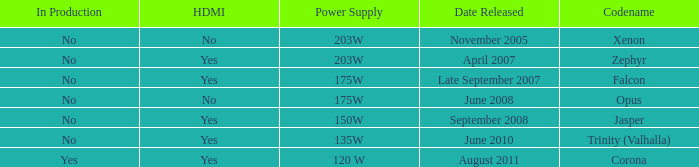Is Jasper being producted? No. Would you be able to parse every entry in this table? {'header': ['In Production', 'HDMI', 'Power Supply', 'Date Released', 'Codename'], 'rows': [['No', 'No', '203W', 'November 2005', 'Xenon'], ['No', 'Yes', '203W', 'April 2007', 'Zephyr'], ['No', 'Yes', '175W', 'Late September 2007', 'Falcon'], ['No', 'No', '175W', 'June 2008', 'Opus'], ['No', 'Yes', '150W', 'September 2008', 'Jasper'], ['No', 'Yes', '135W', 'June 2010', 'Trinity (Valhalla)'], ['Yes', 'Yes', '120 W', 'August 2011', 'Corona']]} 